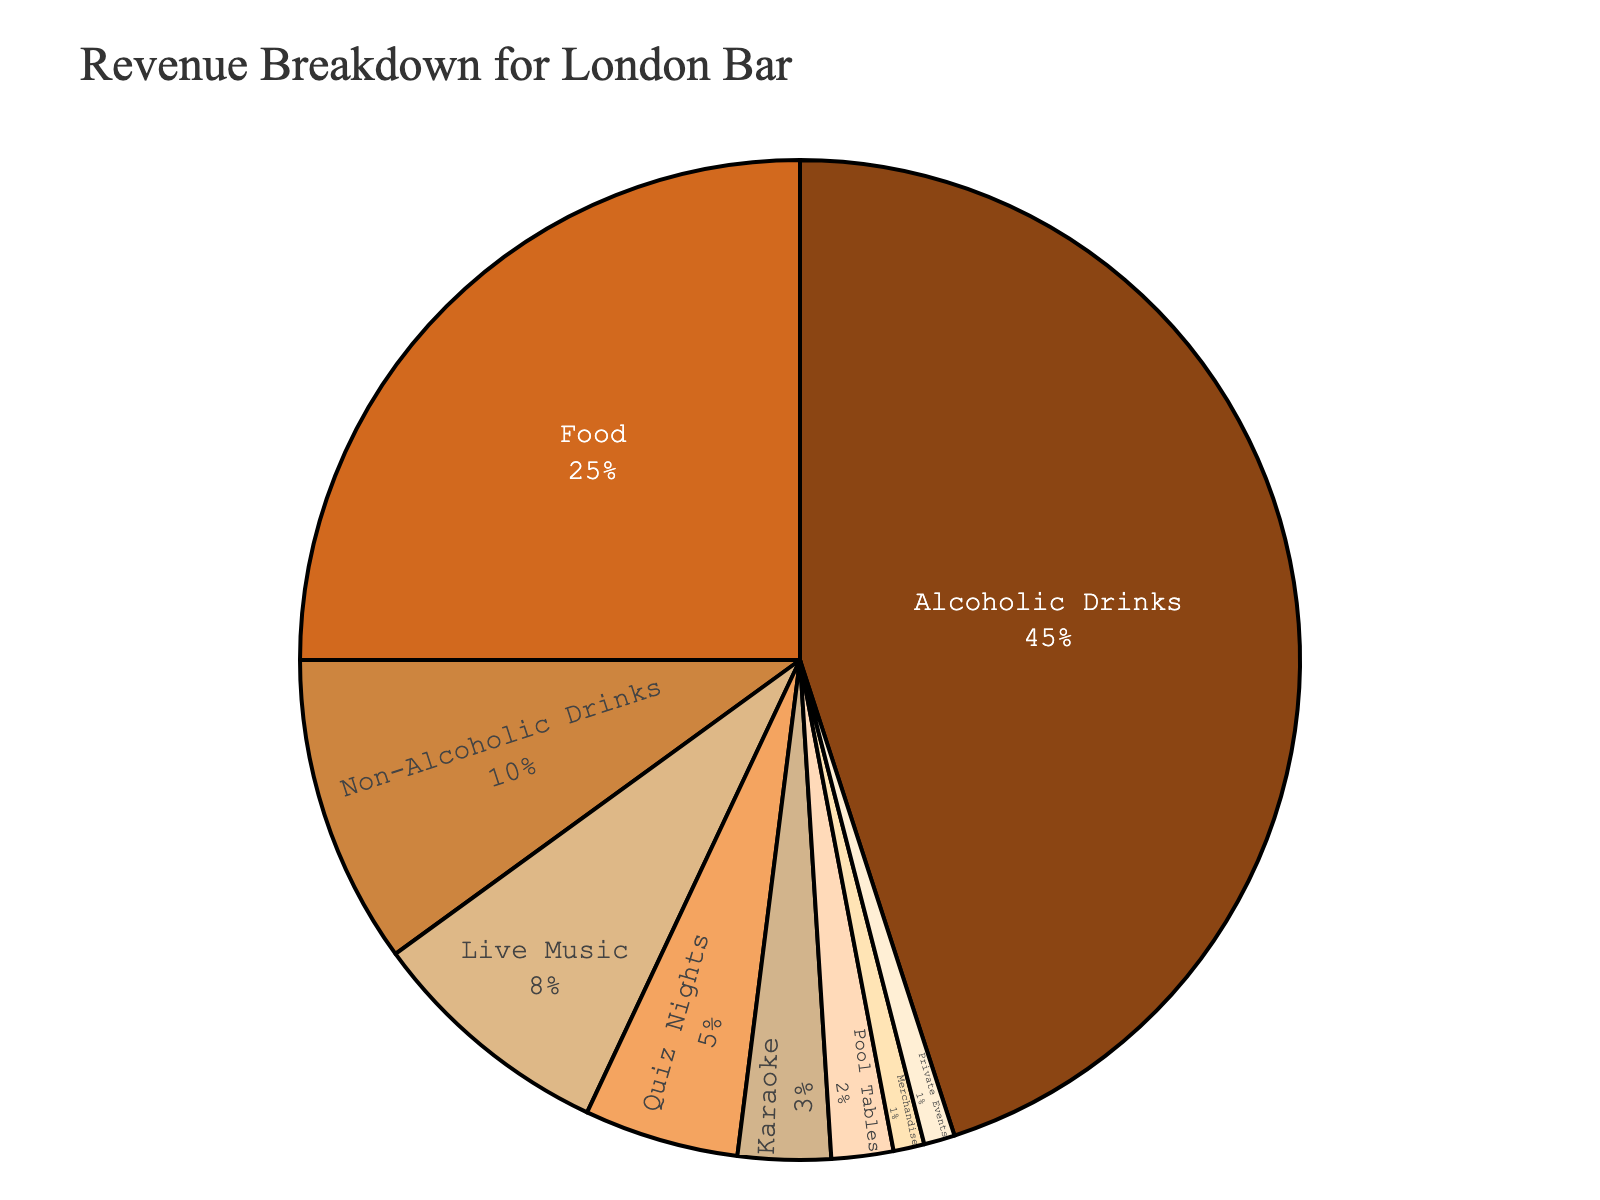Which service contributes the highest percentage of revenue? The largest slice in the pie chart represents the service with the highest revenue percentage.
Answer: Alcoholic Drinks What is the combined percentage of revenue from Non-Alcoholic Drinks and Food? Sum the percentages of Non-Alcoholic Drinks (10%) and Food (25%).
Answer: 35% Which service contributes less revenue: Quiz Nights or Karaoke? Compare the percentages between Quiz Nights (5%) and Karaoke (3%).
Answer: Karaoke What's the difference in the percentage of revenue between Alcoholic Drinks and Live Music? Subtract the percentage of Live Music (8%) from Alcoholic Drinks (45%).
Answer: 37% How much more revenue percentage do Alcoholic Drinks generate compared to Pool Tables and Merchandise combined? First, find the combined percentage of Pool Tables (2%) and Merchandise (1%), which is 3%. Then subtract this from the percentage of Alcoholic Drinks (45%).
Answer: 42% Which services combined generate the same percentage of revenue as Food? Look for services whose percentages add up to 25%. Quiz Nights (5%), Karaoke (3%), Pool Tables (2%), Merchandise (1%), and Private Events (1%) combined give 12%. Adding Live Music (8%) results in 20%. Adding Non-Alcoholic Drinks (10%) individually makes more than 25%. However, combining Non-Alcoholic Drinks (10%) and Live Music (8%) results in 18%, which doesn't meet the requirement. Combining Non-Alcoholic Drinks (10%), Quiz Nights (5%), and Karaoke (3%) results in 18% either. Thus no precise combination equals 25%.
Answer: None If the bar decided to double its revenue from Karaoke, what would be its new percentage contribution? Take the current percentage of Karaoke (3%) and multiply it by 2.
Answer: 6% What's the total percentage of revenue from entertainment services (Live Music, Quiz Nights, Karaoke, Pool Tables)? Sum the percentages of Live Music (8%), Quiz Nights (5%), Karaoke (3%), and Pool Tables (2%).
Answer: 18% How does the revenue from Food compare to the combined revenue from Non-Alcoholic Drinks and Quiz Nights? Compare the percentage from Food (25%) to the sum of Non-Alcoholic Drinks (10%) and Quiz Nights (5%), which is 15%.
Answer: Food has 10% more What is the smallest revenue percentage, and which service does it belong to? Identify the smallest slice in the pie chart and note its percentage and service.
Answer: 1%, Merchandise & Private Events 